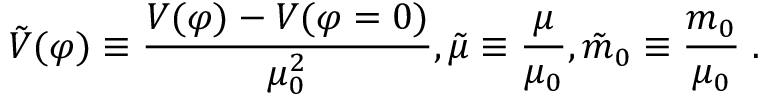Convert formula to latex. <formula><loc_0><loc_0><loc_500><loc_500>{ \tilde { V } } ( \varphi ) \equiv \frac { V ( \varphi ) - V ( \varphi = 0 ) } { \mu _ { 0 } ^ { 2 } } , { \tilde { \mu } } \equiv \frac { \mu } { \mu _ { 0 } } , { \tilde { m } } _ { 0 } \equiv \frac { m _ { 0 } } { \mu _ { 0 } } \, .</formula> 